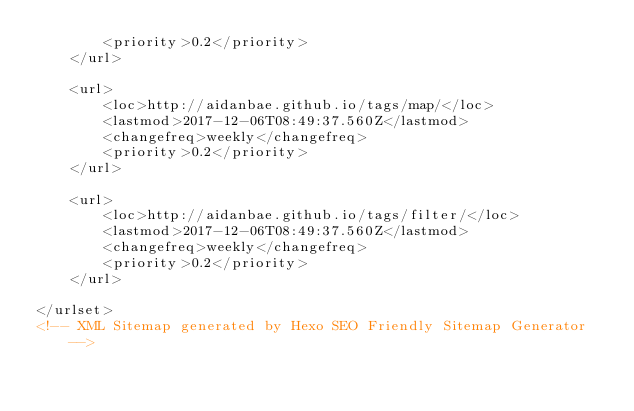Convert code to text. <code><loc_0><loc_0><loc_500><loc_500><_XML_>        <priority>0.2</priority>
    </url>

    <url>
        <loc>http://aidanbae.github.io/tags/map/</loc>
        <lastmod>2017-12-06T08:49:37.560Z</lastmod>
        <changefreq>weekly</changefreq>
        <priority>0.2</priority>
    </url>

    <url>
        <loc>http://aidanbae.github.io/tags/filter/</loc>
        <lastmod>2017-12-06T08:49:37.560Z</lastmod>
        <changefreq>weekly</changefreq>
        <priority>0.2</priority>
    </url>

</urlset>
<!-- XML Sitemap generated by Hexo SEO Friendly Sitemap Generator -->
</code> 